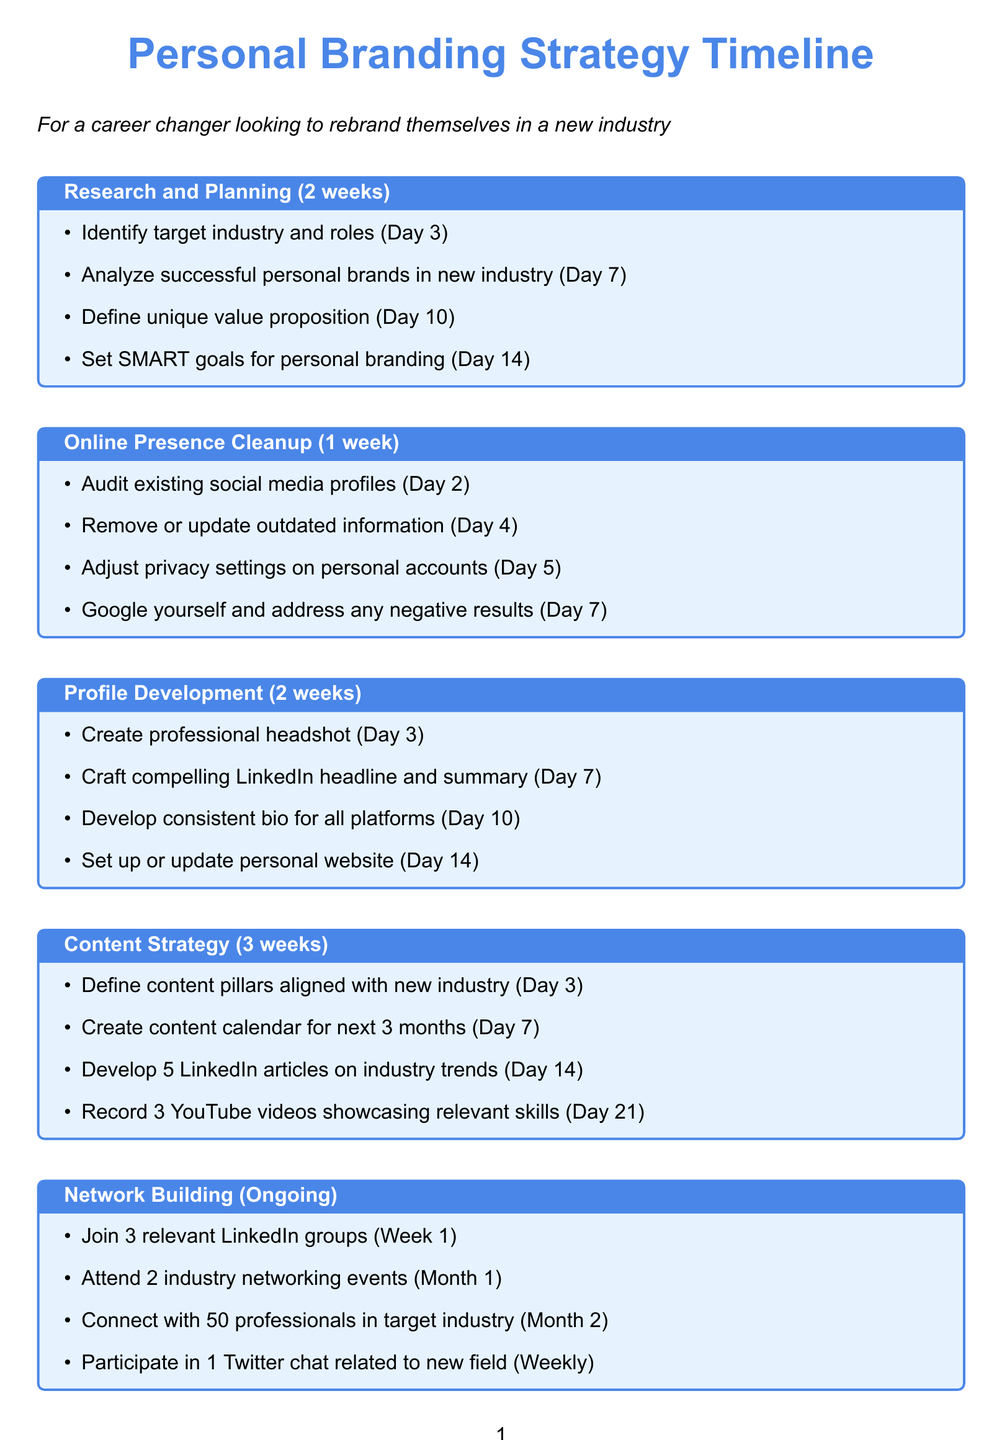what is the duration of the Research and Planning phase? The duration of the Research and Planning phase is specified in the document.
Answer: 2 weeks how many tasks are listed under the Content Strategy phase? The document outlines all tasks in the Content Strategy phase and counts them.
Answer: 4 tasks what is the deadline for creating a professional headshot? The deadline for creating a professional headshot is specified under Profile Development.
Answer: Day 3 how many key projects should be identified for the Portfolio Development? The document specifies the number of key projects to identify in the Portfolio Development section.
Answer: 5 key projects which course should be completed in Month 1 for Skill Development? The document names a specific course to complete in Month 1 under Skill Development.
Answer: Google Digital Marketing course how often should social media engagement metrics be analyzed? This information can be found in the Review and Adjust section of the document.
Answer: Monthly what is the deadline for publishing the portfolio on the personal website? The document provides this information in the Portfolio Development phase.
Answer: Day 28 how many professionals should be connected with in Month 2 during networking? The document indicates the target number of connections to make in Month 2.
Answer: 50 professionals what type of post should be published weekly as part of Engagement and Outreach? The document specifies the type of content to be published in the Engagement and Outreach section.
Answer: Original LinkedIn post 